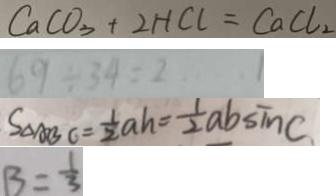<formula> <loc_0><loc_0><loc_500><loc_500>C a C O _ { 3 } + 2 H C l = C a C l _ { 2 } 
 6 9 \div 3 4 = 2 \cdots 1 
 S _ { \Delta A B C } = \frac { 1 } { 2 } a h = \frac { 1 } { 2 } a b \sin C 
 B = \frac { 1 } { 3 }</formula> 